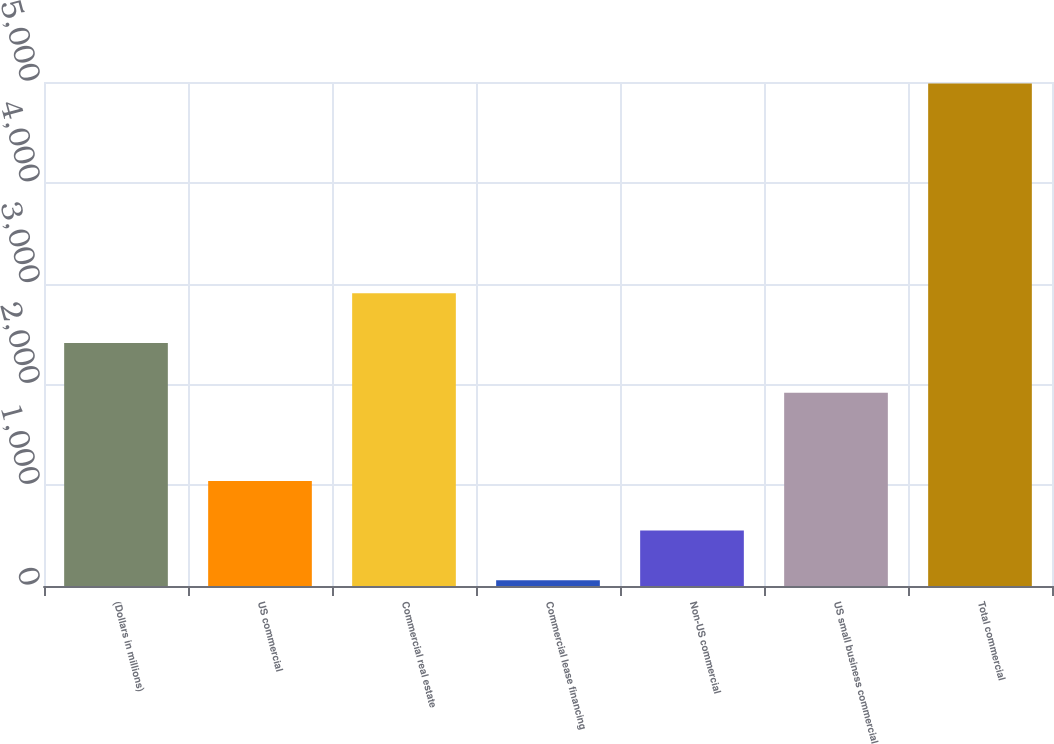Convert chart. <chart><loc_0><loc_0><loc_500><loc_500><bar_chart><fcel>(Dollars in millions)<fcel>US commercial<fcel>Commercial real estate<fcel>Commercial lease financing<fcel>Non-US commercial<fcel>US small business commercial<fcel>Total commercial<nl><fcel>2410.7<fcel>1042.4<fcel>2903.4<fcel>57<fcel>549.7<fcel>1918<fcel>4984<nl></chart> 